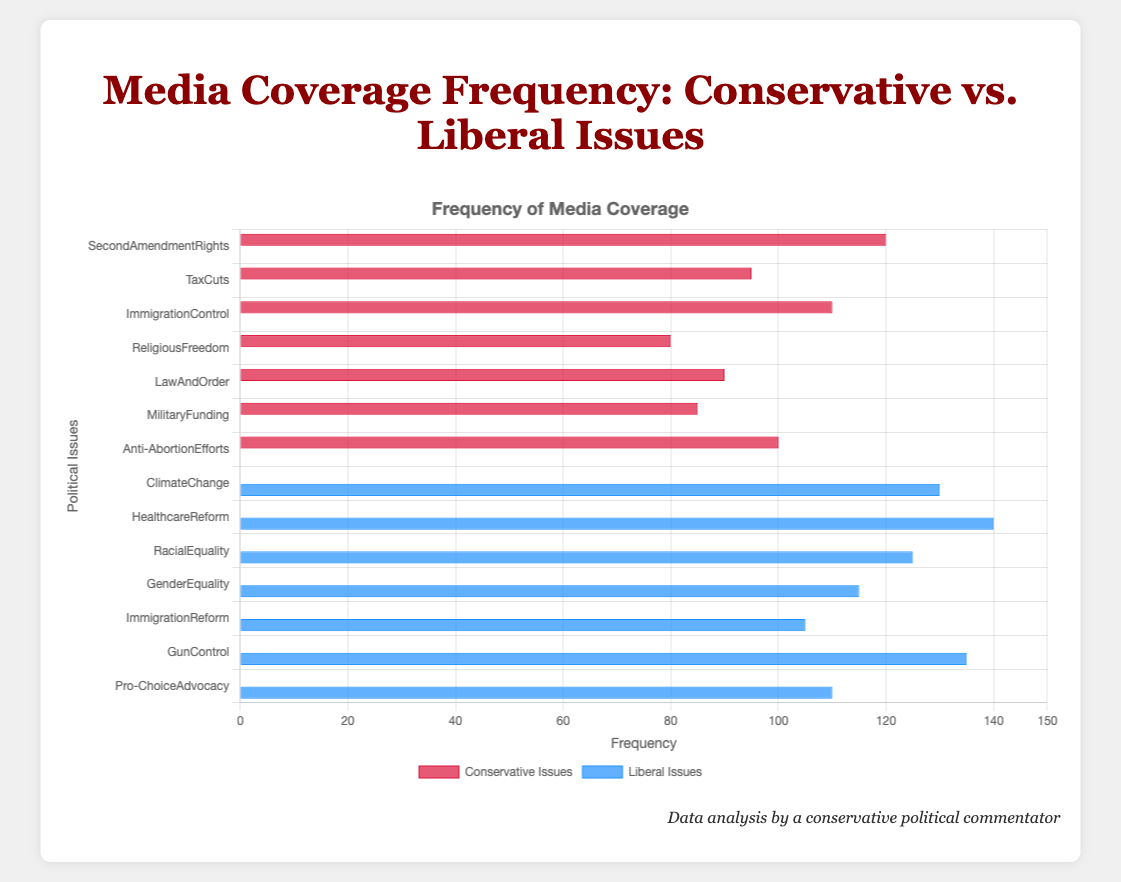Which issue has the highest media coverage frequency among liberal issues? Referring to the plot, the issue that has the tallest bar for liberal issues indicates the highest media coverage frequency. "Healthcare Reform" has the tallest bar.
Answer: Healthcare Reform How much higher is the coverage of Climate Change compared to Law and Order? Look at the bar lengths of Climate Change and Law and Order. Climate Change has a frequency of 130, and Law and Order has a frequency of 90. The difference is 130 - 90.
Answer: 40 Which conservative issue has the least media coverage? The conservative issue with the shortest bar represents the least media coverage. "Religious Freedom" has the shortest bar with 80.
Answer: Religious Freedom Comparing Second Amendment Rights and Gun Control, which issue has more coverage, and by how much? Identify the lengths of the bars for Second Amendment Rights (120) and Gun Control (135). Gun Control has more coverage by 135 - 120.
Answer: Gun Control, 15 What is the average frequency of media coverage for conservative issues? Sum the frequencies for all conservative issues (120 + 95 + 110 + 80 + 90 + 85 + 100) and divide by the number of issues (7). The sum is 680, so the average is 680/7.
Answer: 97.14 Is the media coverage for Pro-Choice Advocacy greater or lesser than Anti-Abortion Efforts? Compare the bar lengths for Pro-Choice Advocacy (110) and Anti-Abortion Efforts (100). Pro-Choice Advocacy has a higher media coverage.
Answer: Greater What is the total media coverage frequency for liberal issues regarding equality (Racial Equality and Gender Equality)? Add the frequencies for Racial Equality (125) and Gender Equality (115). The sum is 125 + 115.
Answer: 240 How does the coverage of Immigration Control compare to Immigration Reform? Compare the bar lengths for Immigration Control (110) and Immigration Reform (105). Immigration Control has slightly more coverage by 110 - 105.
Answer: 5 Which issue has the lowest media coverage frequency among all listed liberal issues? The liberal issue with the shortest bar has the lowest media coverage frequency. "Immigration Reform" with a frequency of 105 has the shortest bar.
Answer: Immigration Reform What is the combined media coverage frequency for Second Amendment Rights and Gun Control? Add the frequencies for Second Amendment Rights (120) and Gun Control (135). The sum is 120 + 135.
Answer: 255 